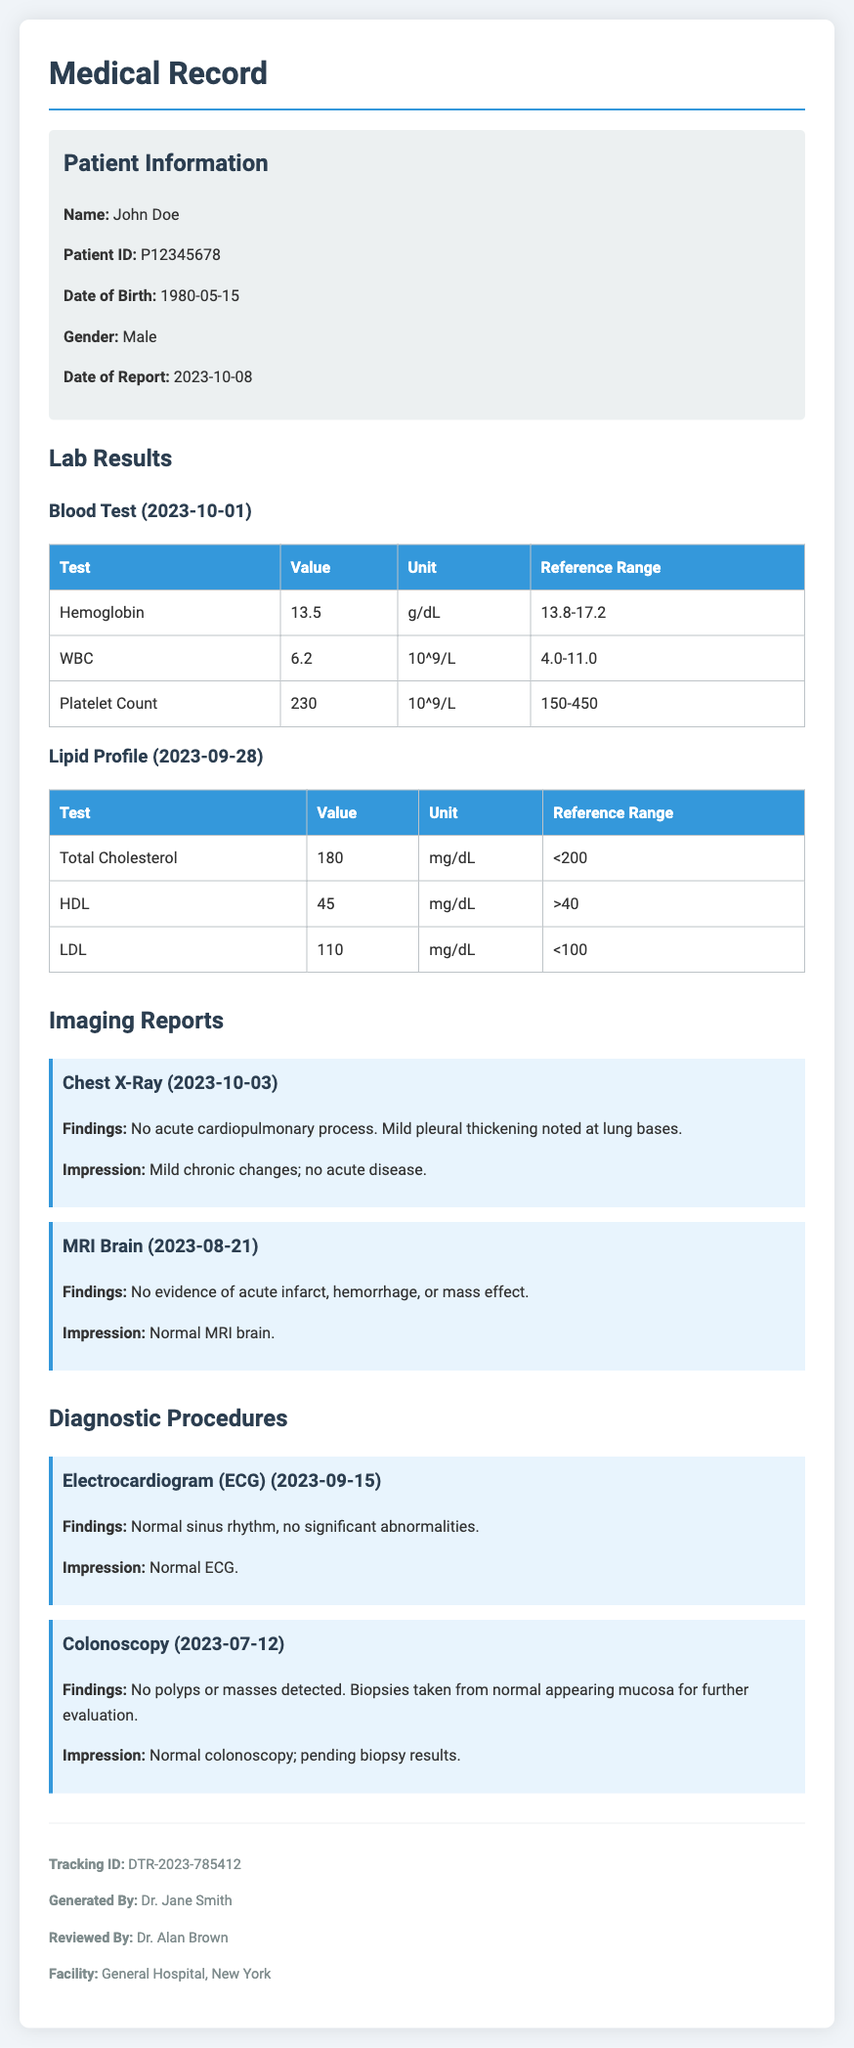What is the patient's name? The patient's name is listed in the Patient Information section.
Answer: John Doe What was the date of the Blood Test? The date is specified next to the test in the Lab Results section.
Answer: 2023-10-01 What was the value of HDL in the Lipid Profile? The value is recorded under the Lipid Profile test results.
Answer: 45 What were the findings of the Chest X-Ray? The findings are documented in the Imaging Reports section.
Answer: No acute cardiopulmonary process. Mild pleural thickening noted at lung bases What is the impression of the Colonoscopy? The impression is stated along with the findings in the Diagnostic Procedures section.
Answer: Normal colonoscopy; pending biopsy results Did the MRI Brain show any abnormalities? This question requires reasoning about the imaging report findings.
Answer: No What is the reference range for Hemoglobin? The reference range is included in the lab test documentation in the document.
Answer: 13.8-17.2 Who generated the report? The report generator's name is noted in the metadata at the end of the document.
Answer: Dr. Jane Smith What is the Tracking ID of this medical record? The Tracking ID is listed in the metadata section.
Answer: DTR-2023-785412 